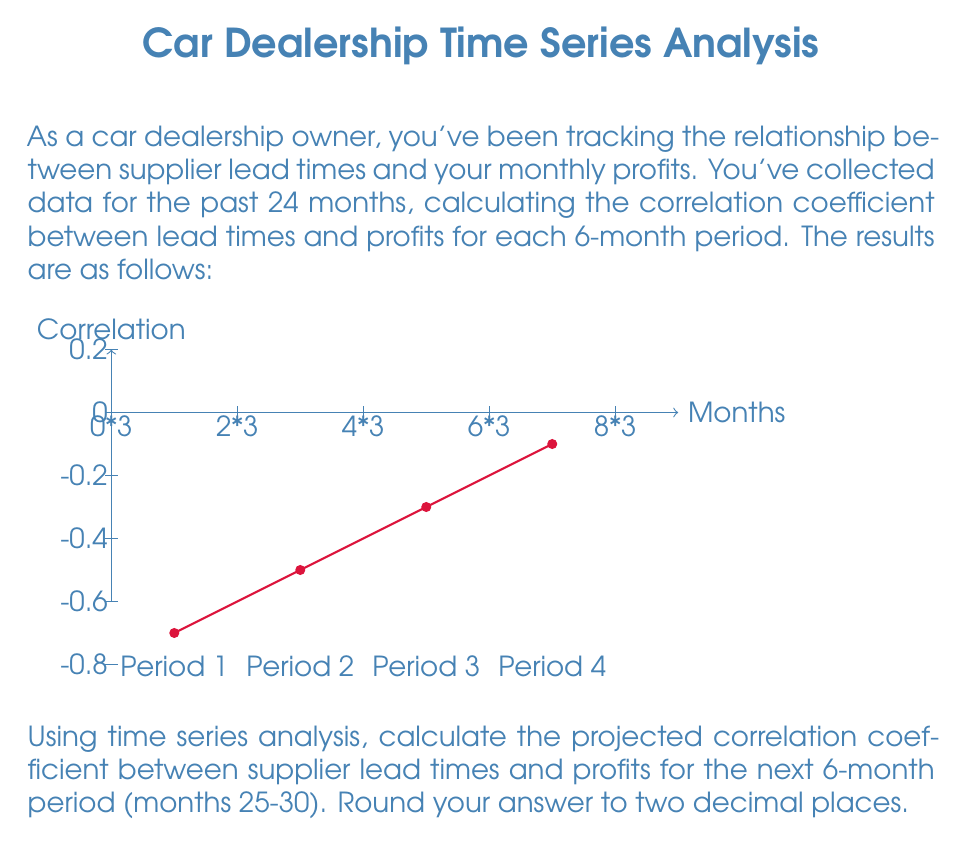Provide a solution to this math problem. To solve this problem, we'll use linear regression on the time series data to project the future correlation coefficient. Here's a step-by-step approach:

1) First, let's identify our data points:
   Time (x): 3, 9, 15, 21 (midpoints of each 6-month period)
   Correlation (y): -0.7, -0.5, -0.3, -0.1

2) We'll use the formula for the slope of the linear regression line:

   $$m = \frac{n\sum xy - \sum x \sum y}{n\sum x^2 - (\sum x)^2}$$

   Where n is the number of data points (4 in this case).

3) Calculate the necessary sums:
   $\sum x = 3 + 9 + 15 + 21 = 48$
   $\sum y = -0.7 + (-0.5) + (-0.3) + (-0.1) = -1.6$
   $\sum xy = (3)(-0.7) + (9)(-0.5) + (15)(-0.3) + (21)(-0.1) = -16.2$
   $\sum x^2 = 3^2 + 9^2 + 15^2 + 21^2 = 756$

4) Plug these values into the slope formula:

   $$m = \frac{4(-16.2) - (48)(-1.6)}{4(756) - 48^2} = \frac{12}{1152} = \frac{1}{96} \approx 0.0104$$

5) Now we can find the y-intercept (b) using the formula:
   $$b = \bar{y} - m\bar{x}$$

   Where $\bar{x}$ and $\bar{y}$ are the means of x and y respectively.

   $\bar{x} = 48/4 = 12$
   $\bar{y} = -1.6/4 = -0.4$

   $$b = -0.4 - (0.0104)(12) = -0.5248$$

6) Our regression line equation is thus:
   $$y = 0.0104x - 0.5248$$

7) To project the correlation for the next period, we use x = 27 (midpoint of months 25-30):

   $$y = 0.0104(27) - 0.5248 = -0.2440$$

8) Rounding to two decimal places: -0.24
Answer: -0.24 